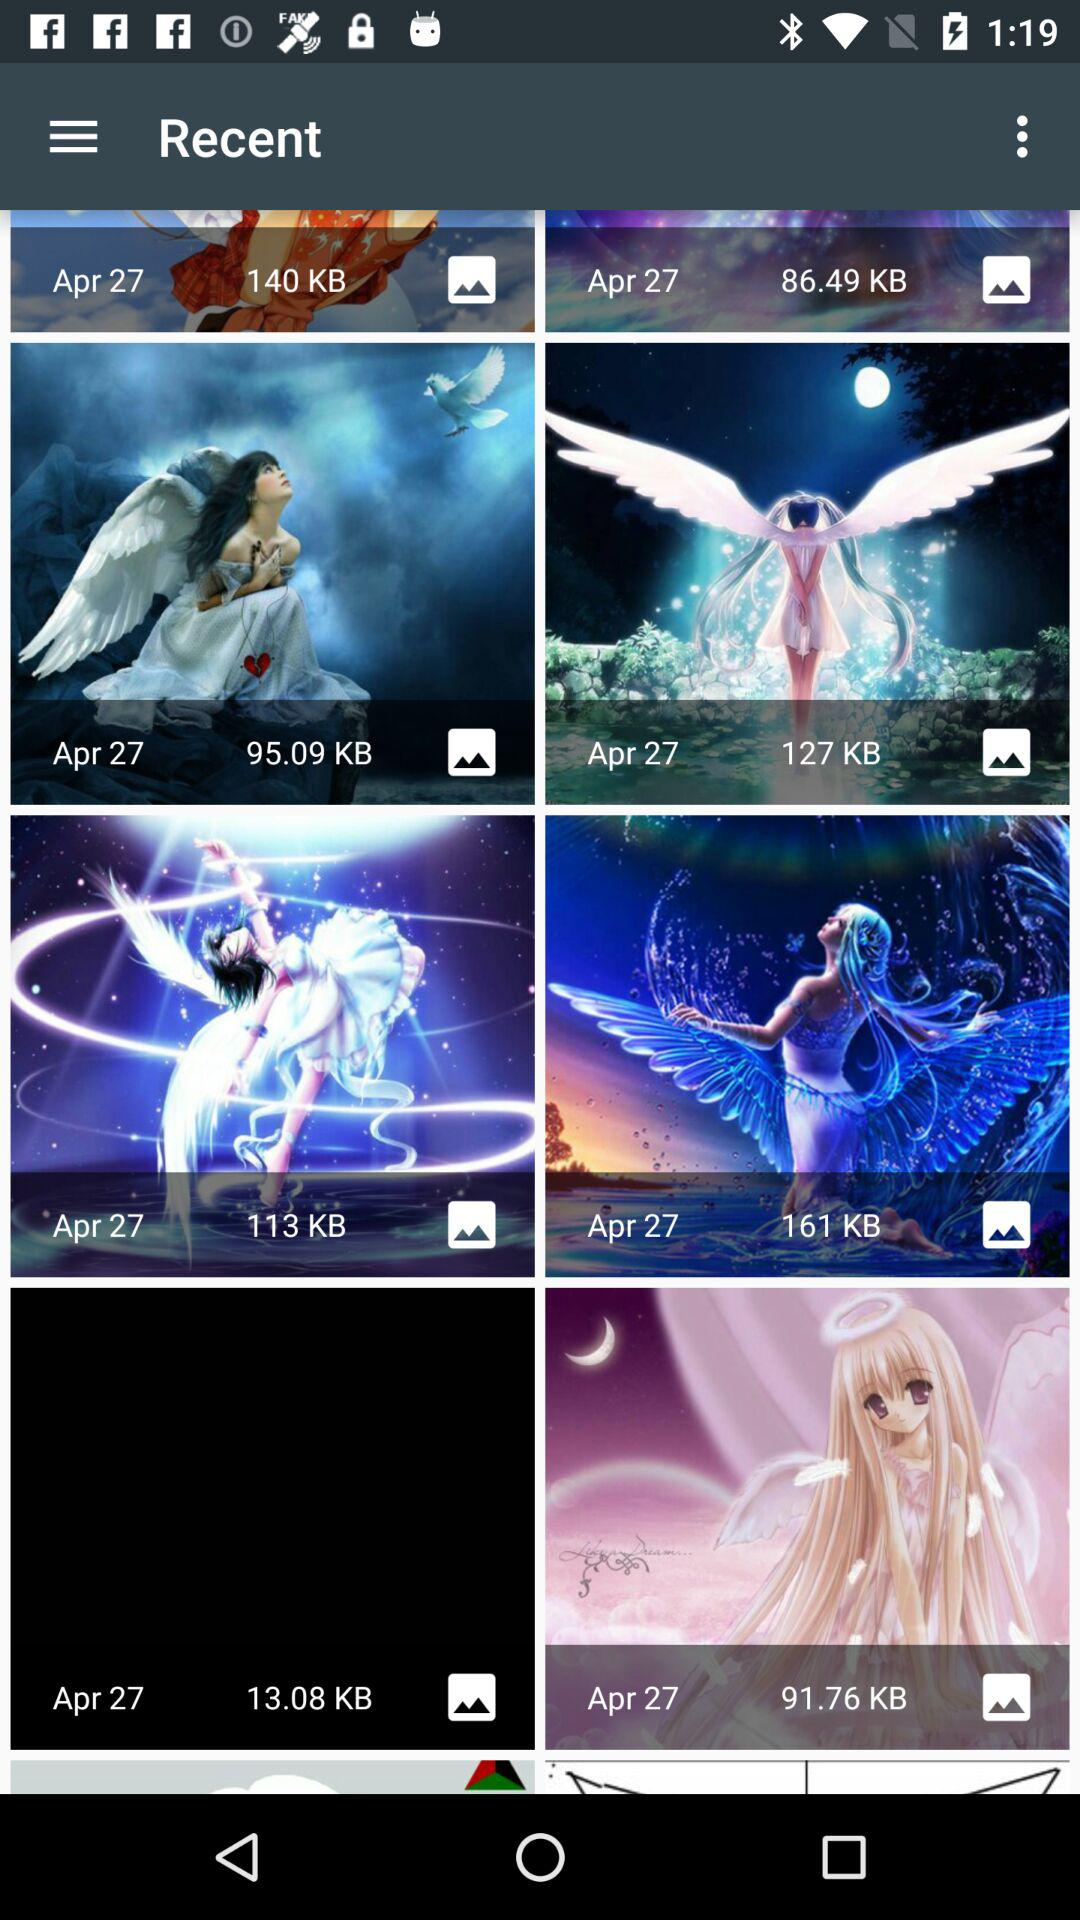What is the date? The date is April 27. 